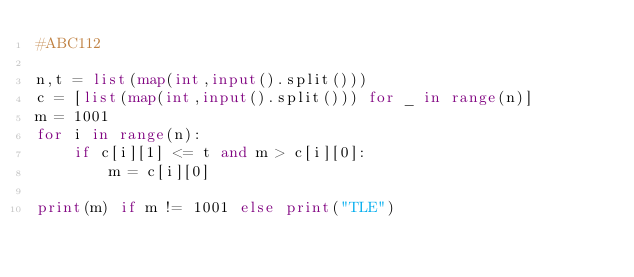Convert code to text. <code><loc_0><loc_0><loc_500><loc_500><_Python_>#ABC112
    
n,t = list(map(int,input().split()))
c = [list(map(int,input().split())) for _ in range(n)]
m = 1001
for i in range(n):
    if c[i][1] <= t and m > c[i][0]:
        m = c[i][0]
        
print(m) if m != 1001 else print("TLE")




</code> 